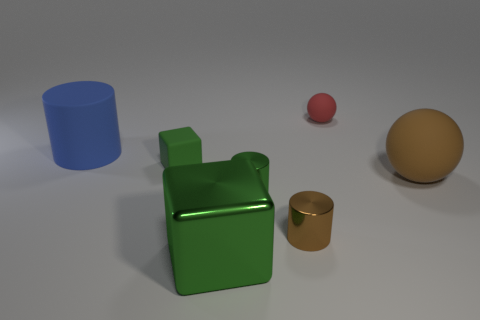There is a large rubber thing to the left of the ball in front of the small rubber object right of the small rubber block; what shape is it?
Give a very brief answer. Cylinder. Is there any other thing that has the same shape as the green matte thing?
Your answer should be very brief. Yes. How many cubes are either brown metal objects or blue objects?
Offer a terse response. 0. There is a small rubber object that is in front of the large blue matte cylinder; does it have the same color as the big cube?
Your answer should be very brief. Yes. What is the material of the block behind the tiny metal cylinder that is in front of the green metal thing behind the green shiny cube?
Offer a terse response. Rubber. Does the green cylinder have the same size as the blue matte cylinder?
Keep it short and to the point. No. Do the tiny cube and the block that is in front of the small brown metal cylinder have the same color?
Keep it short and to the point. Yes. What shape is the large green object that is the same material as the green cylinder?
Give a very brief answer. Cube. There is a tiny matte object that is in front of the blue cylinder; does it have the same shape as the blue rubber thing?
Your answer should be compact. No. There is a green metal thing behind the small cylinder that is right of the green cylinder; what size is it?
Offer a terse response. Small. 